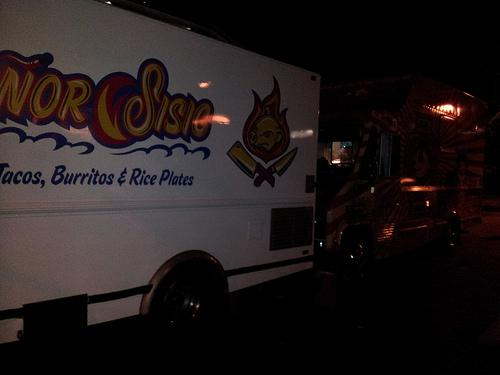Question: when was the picture taken?
Choices:
A. Early evening.
B. Night.
C. Midnight.
D. Just before dawn.
Answer with the letter. Answer: B Question: how many utensils are on the truck?
Choices:
A. One.
B. Two.
C. Zero.
D. Five.
Answer with the letter. Answer: B Question: what color is the print on the truck?
Choices:
A. Orange.
B. Blue.
C. Black.
D. Red.
Answer with the letter. Answer: B Question: how many products are shown on the truck?
Choices:
A. Seven.
B. Three.
C. Two.
D. Five.
Answer with the letter. Answer: B Question: how many trucks are shown?
Choices:
A. Two.
B. One.
C. None.
D. Four.
Answer with the letter. Answer: A 